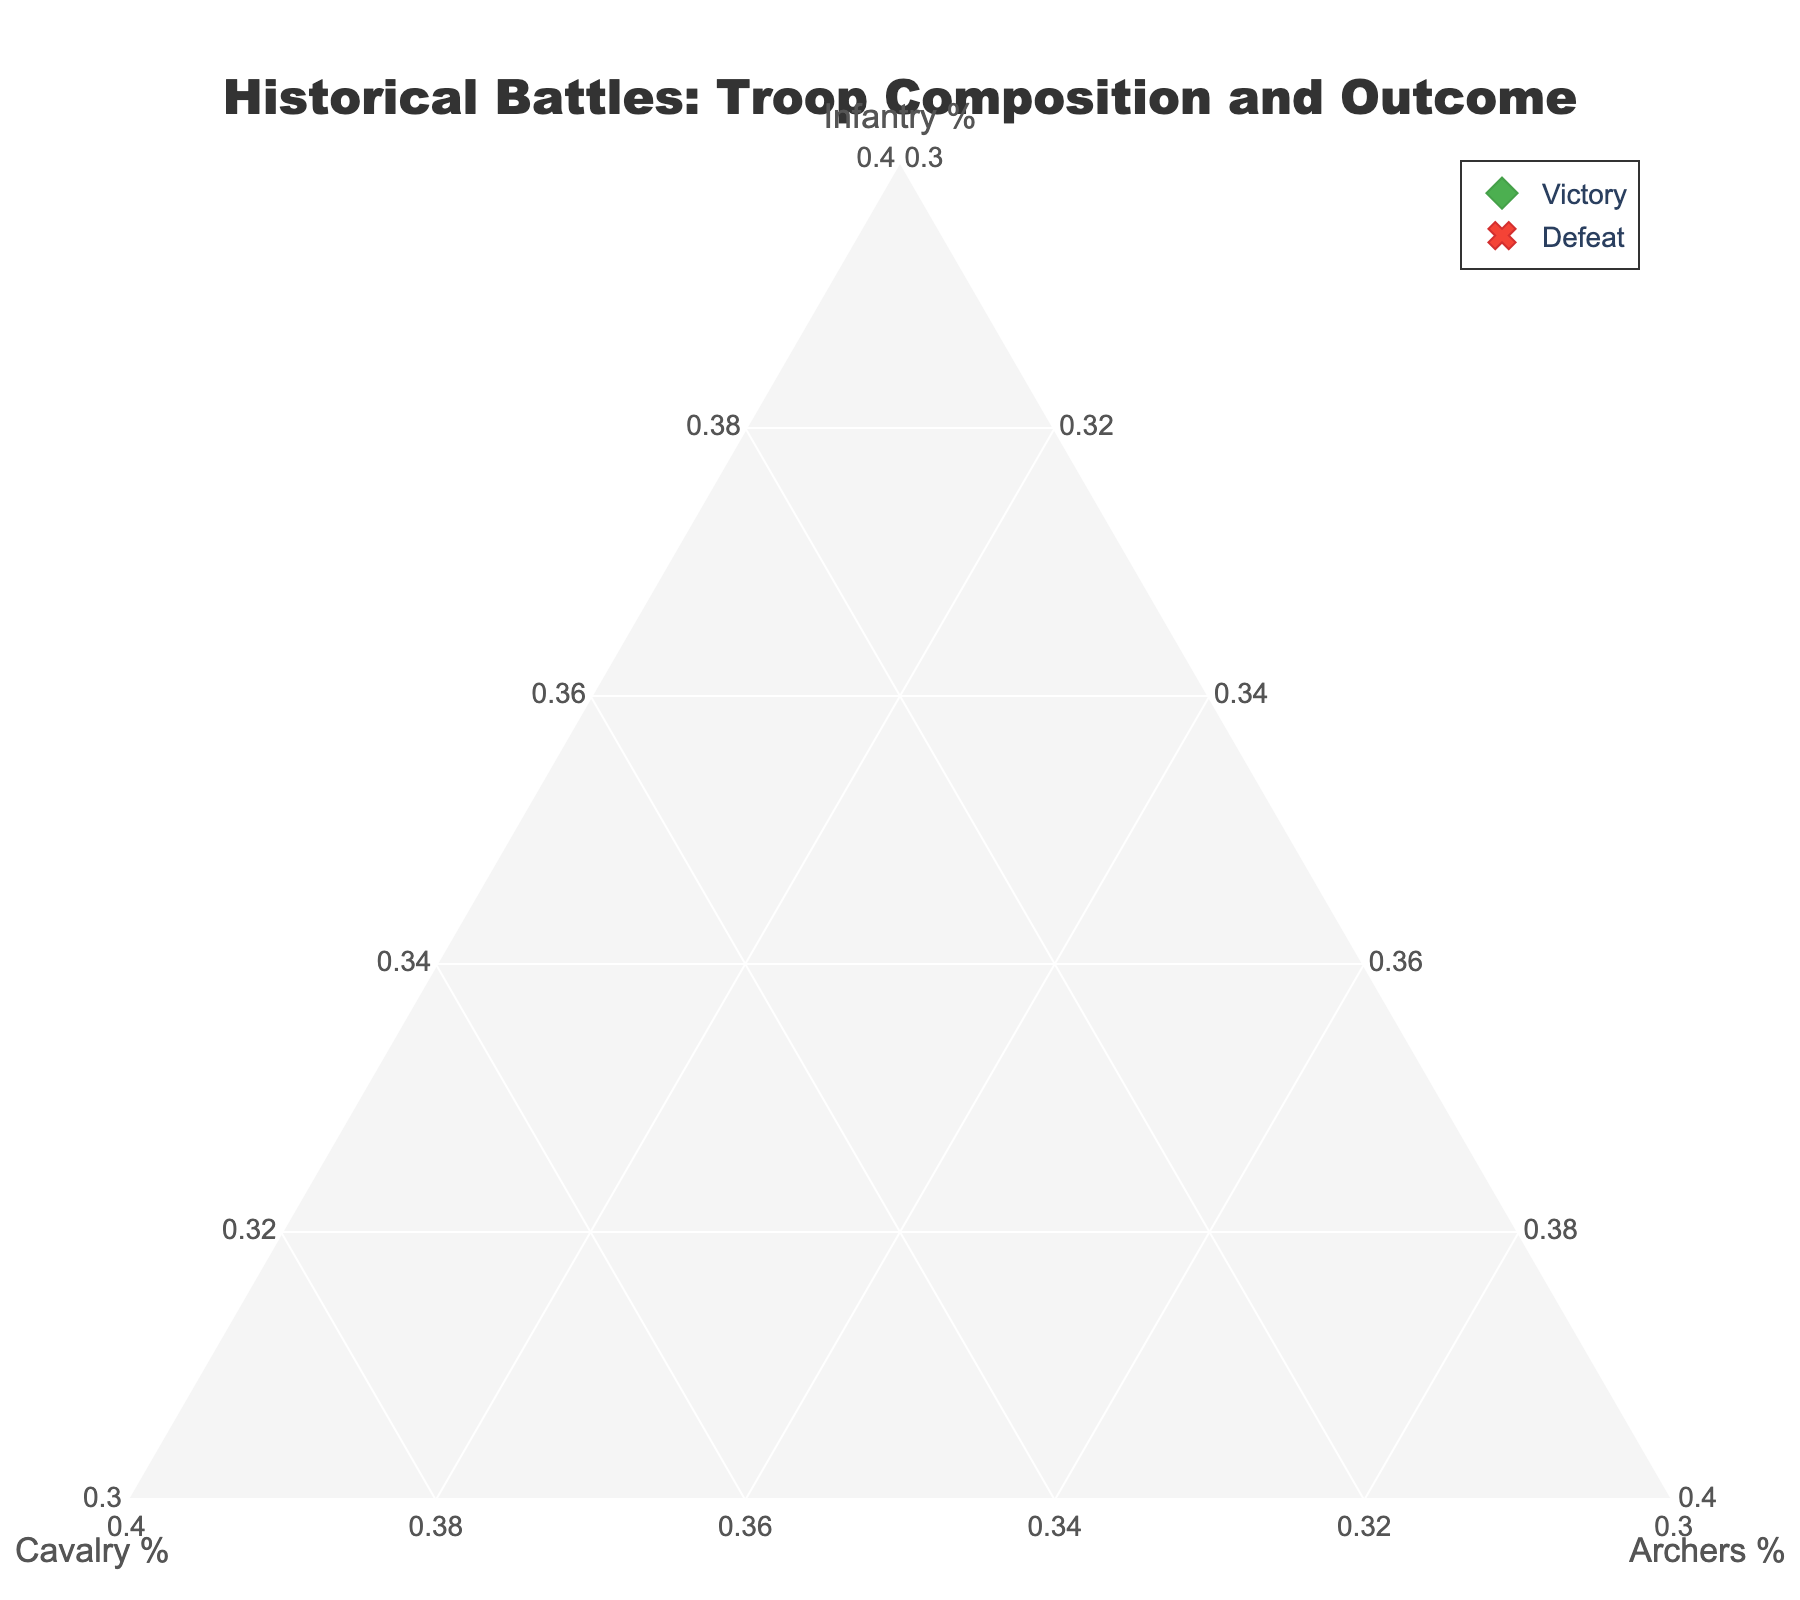what is the title of the figure? Look at the top of the plot to find the title text
Answer: Historical Battles: Troop Composition and Outcome How many battles resulted in victory? Count the number of green diamond markers, which represent victories on the plot
Answer: 12 Which battle had the highest percentage of cavalry? Locate the marker that is closest to the Cavalry % axis with the highest value
Answer: Battle of Mohács What is the main color used to indicate defeats in the plot? Identify the color of the markers that represent defeats, which are marked with 'x' symbols
Answer: Red What are the infantry, cavalry, and archers percentages in the Battle of Bannockburn? Hover or look at the point labeled "Battle of Bannockburn" and note the percentages in the hover template
Answer: 65% Infantry, 30% Cavalry, 5% Archers What's the difference in infantry percentage between the Battle of Pavia and the Battle of Lepanto? Find the infantry percentages for both battles and subtract them: Pavia (45%) and Lepanto (30%)
Answer: 15% Which battle shows an equal distribution between Cavalry and Archers? Identify any battle where the percentages of Cavalry and Archers are equal. There is no such battle in the provided data
Answer: None Which battle closely balances infantry and cavalry troops with minimal archers? Find the data point closest to equally distributed infantry and cavalry, and minimal archers. Battle of Austerlitz is the closest
Answer: Battle of Austerlitz Do victories generally have a higher proportion of infantry compared to defeats? Look for the concentration of green diamond markers (victories) and red x markers (defeats) on the Infantry axis
Answer: Yes What is the average infantry percentage for all defeat outcomes? Find the infantry percentages for all defeats (Falkirk, Mohács, and Austerlitz) and calculate the mean, i.e., (40 + 35 + 60) / 3
Answer: 45% 